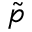<formula> <loc_0><loc_0><loc_500><loc_500>\tilde { p }</formula> 